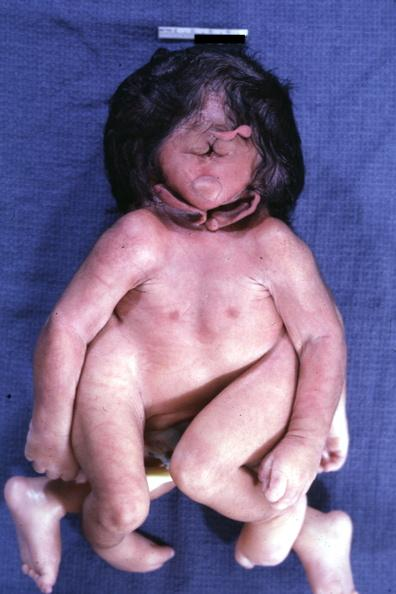does this image show conjoined twins at head and chest?
Answer the question using a single word or phrase. Yes 